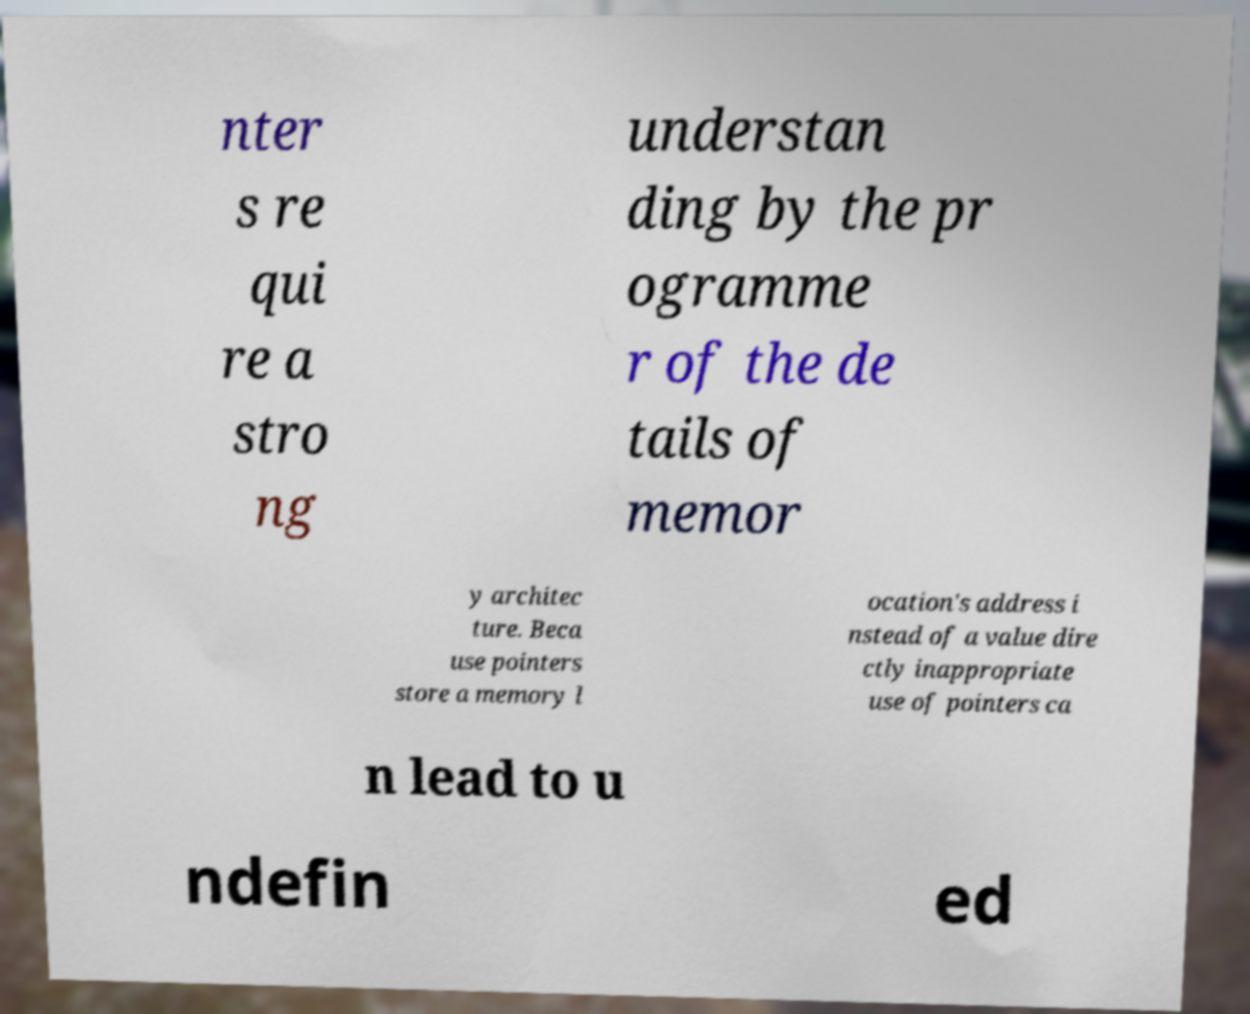I need the written content from this picture converted into text. Can you do that? nter s re qui re a stro ng understan ding by the pr ogramme r of the de tails of memor y architec ture. Beca use pointers store a memory l ocation's address i nstead of a value dire ctly inappropriate use of pointers ca n lead to u ndefin ed 